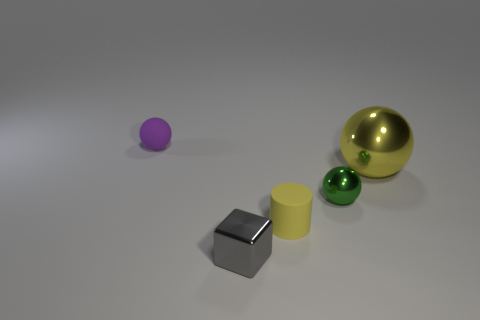Subtract all small green balls. How many balls are left? 2 Add 3 green shiny things. How many objects exist? 8 Subtract all purple spheres. How many spheres are left? 2 Subtract all blocks. How many objects are left? 4 Subtract 1 balls. How many balls are left? 2 Add 1 tiny gray objects. How many tiny gray objects exist? 2 Subtract 1 gray blocks. How many objects are left? 4 Subtract all yellow balls. Subtract all brown blocks. How many balls are left? 2 Subtract all cyan shiny blocks. Subtract all spheres. How many objects are left? 2 Add 3 tiny purple objects. How many tiny purple objects are left? 4 